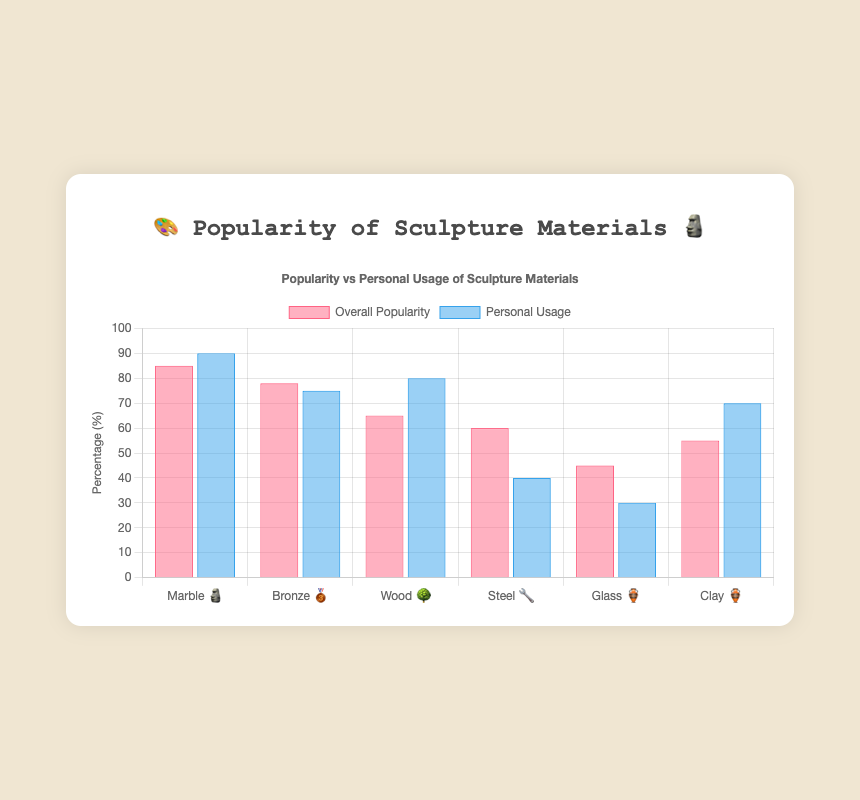How many materials are represented in the chart? The chart lists all the sculpture materials under the "labels" property, which includes six materials: Marble 🗿, Bronze 🥉, Wood 🌳, Steel 🔧, Glass 🏺, and Clay 🏺.
Answer: 6 Which material has the highest overall popularity and what is its percentage? Looking at the bar labeled "Overall Popularity," Marble 🗿 has the highest percentage.
Answer: Marble 🗿, 85% What's the difference in personal usage between Marble 🗿 and Steel 🔧? Marble 🗿 has a personal usage of 90, while Steel 🔧 has a personal usage of 40, so the difference is 90 - 40 = 50.
Answer: 50 Which material has a higher overall popularity: Bronze 🥉 or Wood 🌳? Comparing the bars labeled "Overall Popularity" for Bronze 🥉 (78) and Wood 🌳 (65), Bronze 🥉 has a higher overall popularity.
Answer: Bronze 🥉 What is the average overall popularity of all materials? Adding the overall popularity percentages for all six materials: 85 + 78 + 65 + 60 + 45 + 55 = 388. Dividing by 6 gives us the average: 388 / 6 ≈ 64.67.
Answer: 64.67 Which material has the lowest personal usage and what is its percentage? Looking at the bar labeled "Personal Usage," Glass 🏺 has the lowest percentage at 30.
Answer: Glass 🏺, 30% What's the combined popularity percentage of the two materials with the lowest overall popularity? The two materials with the lowest overall popularity are Glass 🏺 (45) and Clay 🏺 (55). The combined percentage is 45 + 55 = 100.
Answer: 100 Is there any material where personal usage is higher than its overall popularity? Marble 🗿 has a personal usage of 90, which is higher than its overall popularity of 85. Wood 🌳 and Clay 🏺 also have higher personal usage compared to their overall popularity.
Answer: Yes, three materials What percentage of the total overall popularity is represented by Steel 🔧? The total overall popularity is 85 + 78 + 65 + 60 + 45 + 55 = 388. The percentage represented by Steel 🔧 is (60 / 388) * 100 ≈ 15.46%.
Answer: 15.46% If we combine the personal usage of Wood 🌳 and Clay 🏺, what percentage does it represent out of the total personal usage? The personal usage of Wood 🌳 is 80 and Clay 🏺 is 70, so combined is 80 + 70 = 150. The total personal usage is 90 + 75 + 80 + 40 + 30 + 70 = 385. The percentage is (150 / 385) * 100 ≈ 38.96%.
Answer: 38.96% 